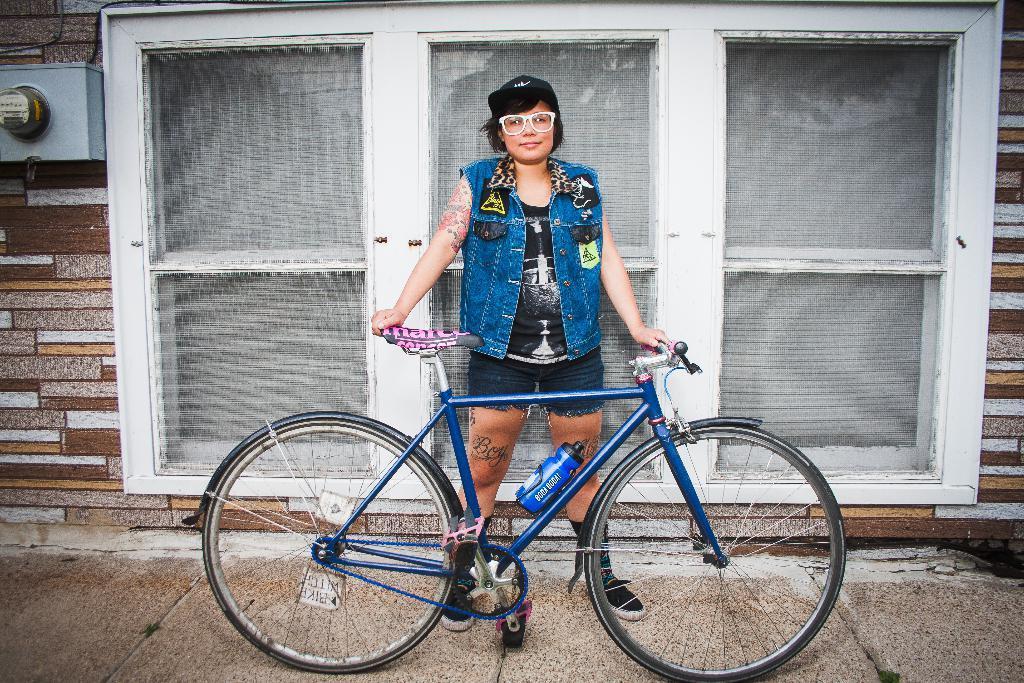Can you describe this image briefly? In this picture we can see a person standing and holding a bicycle, in the background there is a wall, we can see glass windows here. 